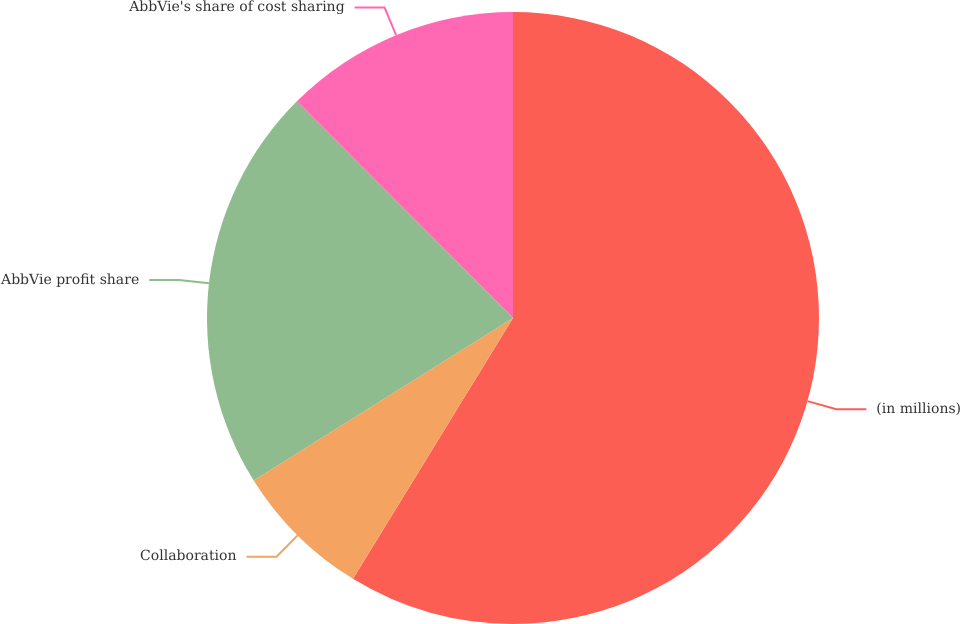Convert chart. <chart><loc_0><loc_0><loc_500><loc_500><pie_chart><fcel>(in millions)<fcel>Collaboration<fcel>AbbVie profit share<fcel>AbbVie's share of cost sharing<nl><fcel>58.75%<fcel>7.34%<fcel>21.42%<fcel>12.48%<nl></chart> 